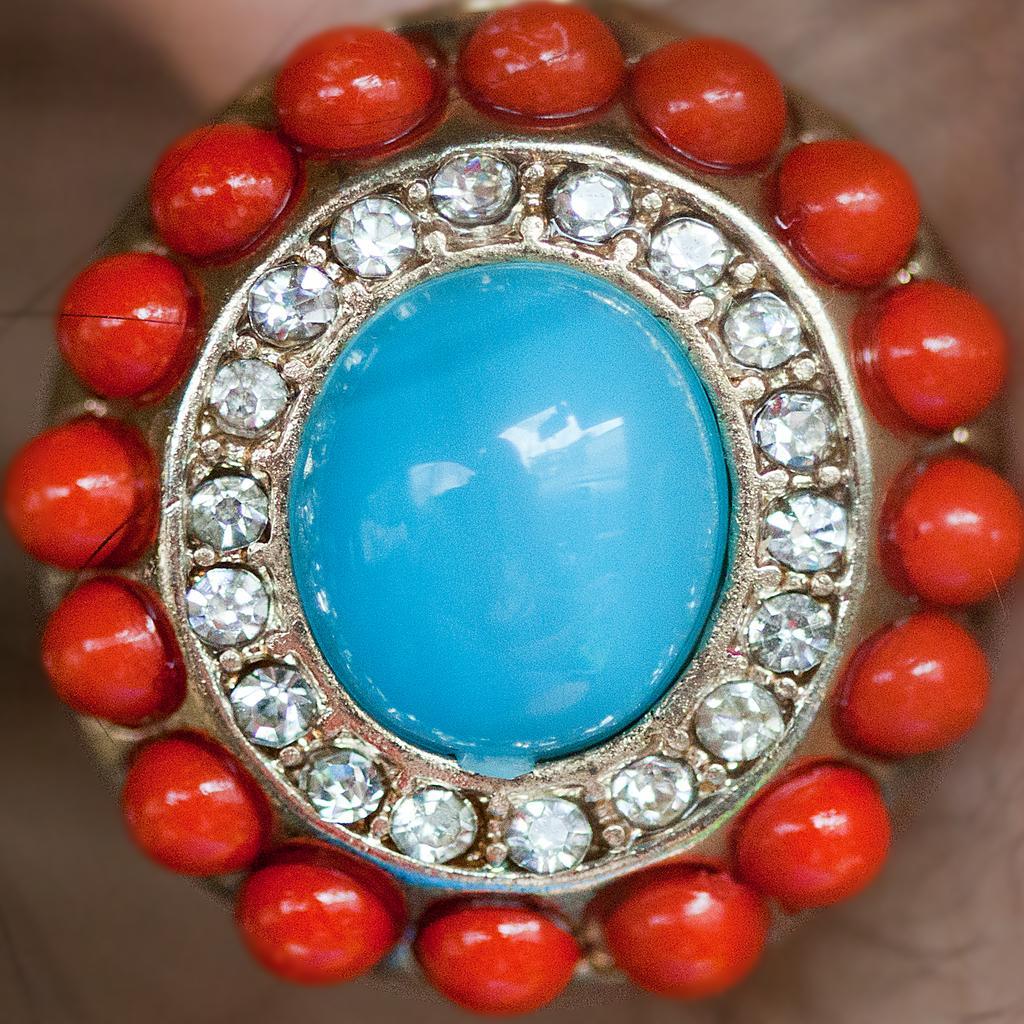How would you summarize this image in a sentence or two? In this image I can see it looks like a locket in some person's hand. 